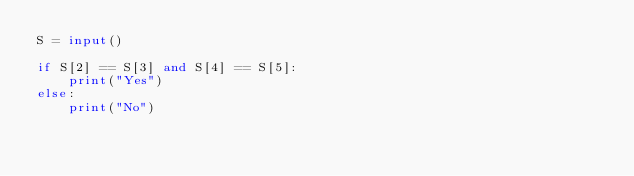Convert code to text. <code><loc_0><loc_0><loc_500><loc_500><_Python_>S = input()

if S[2] == S[3] and S[4] == S[5]:
    print("Yes")
else:
    print("No")</code> 